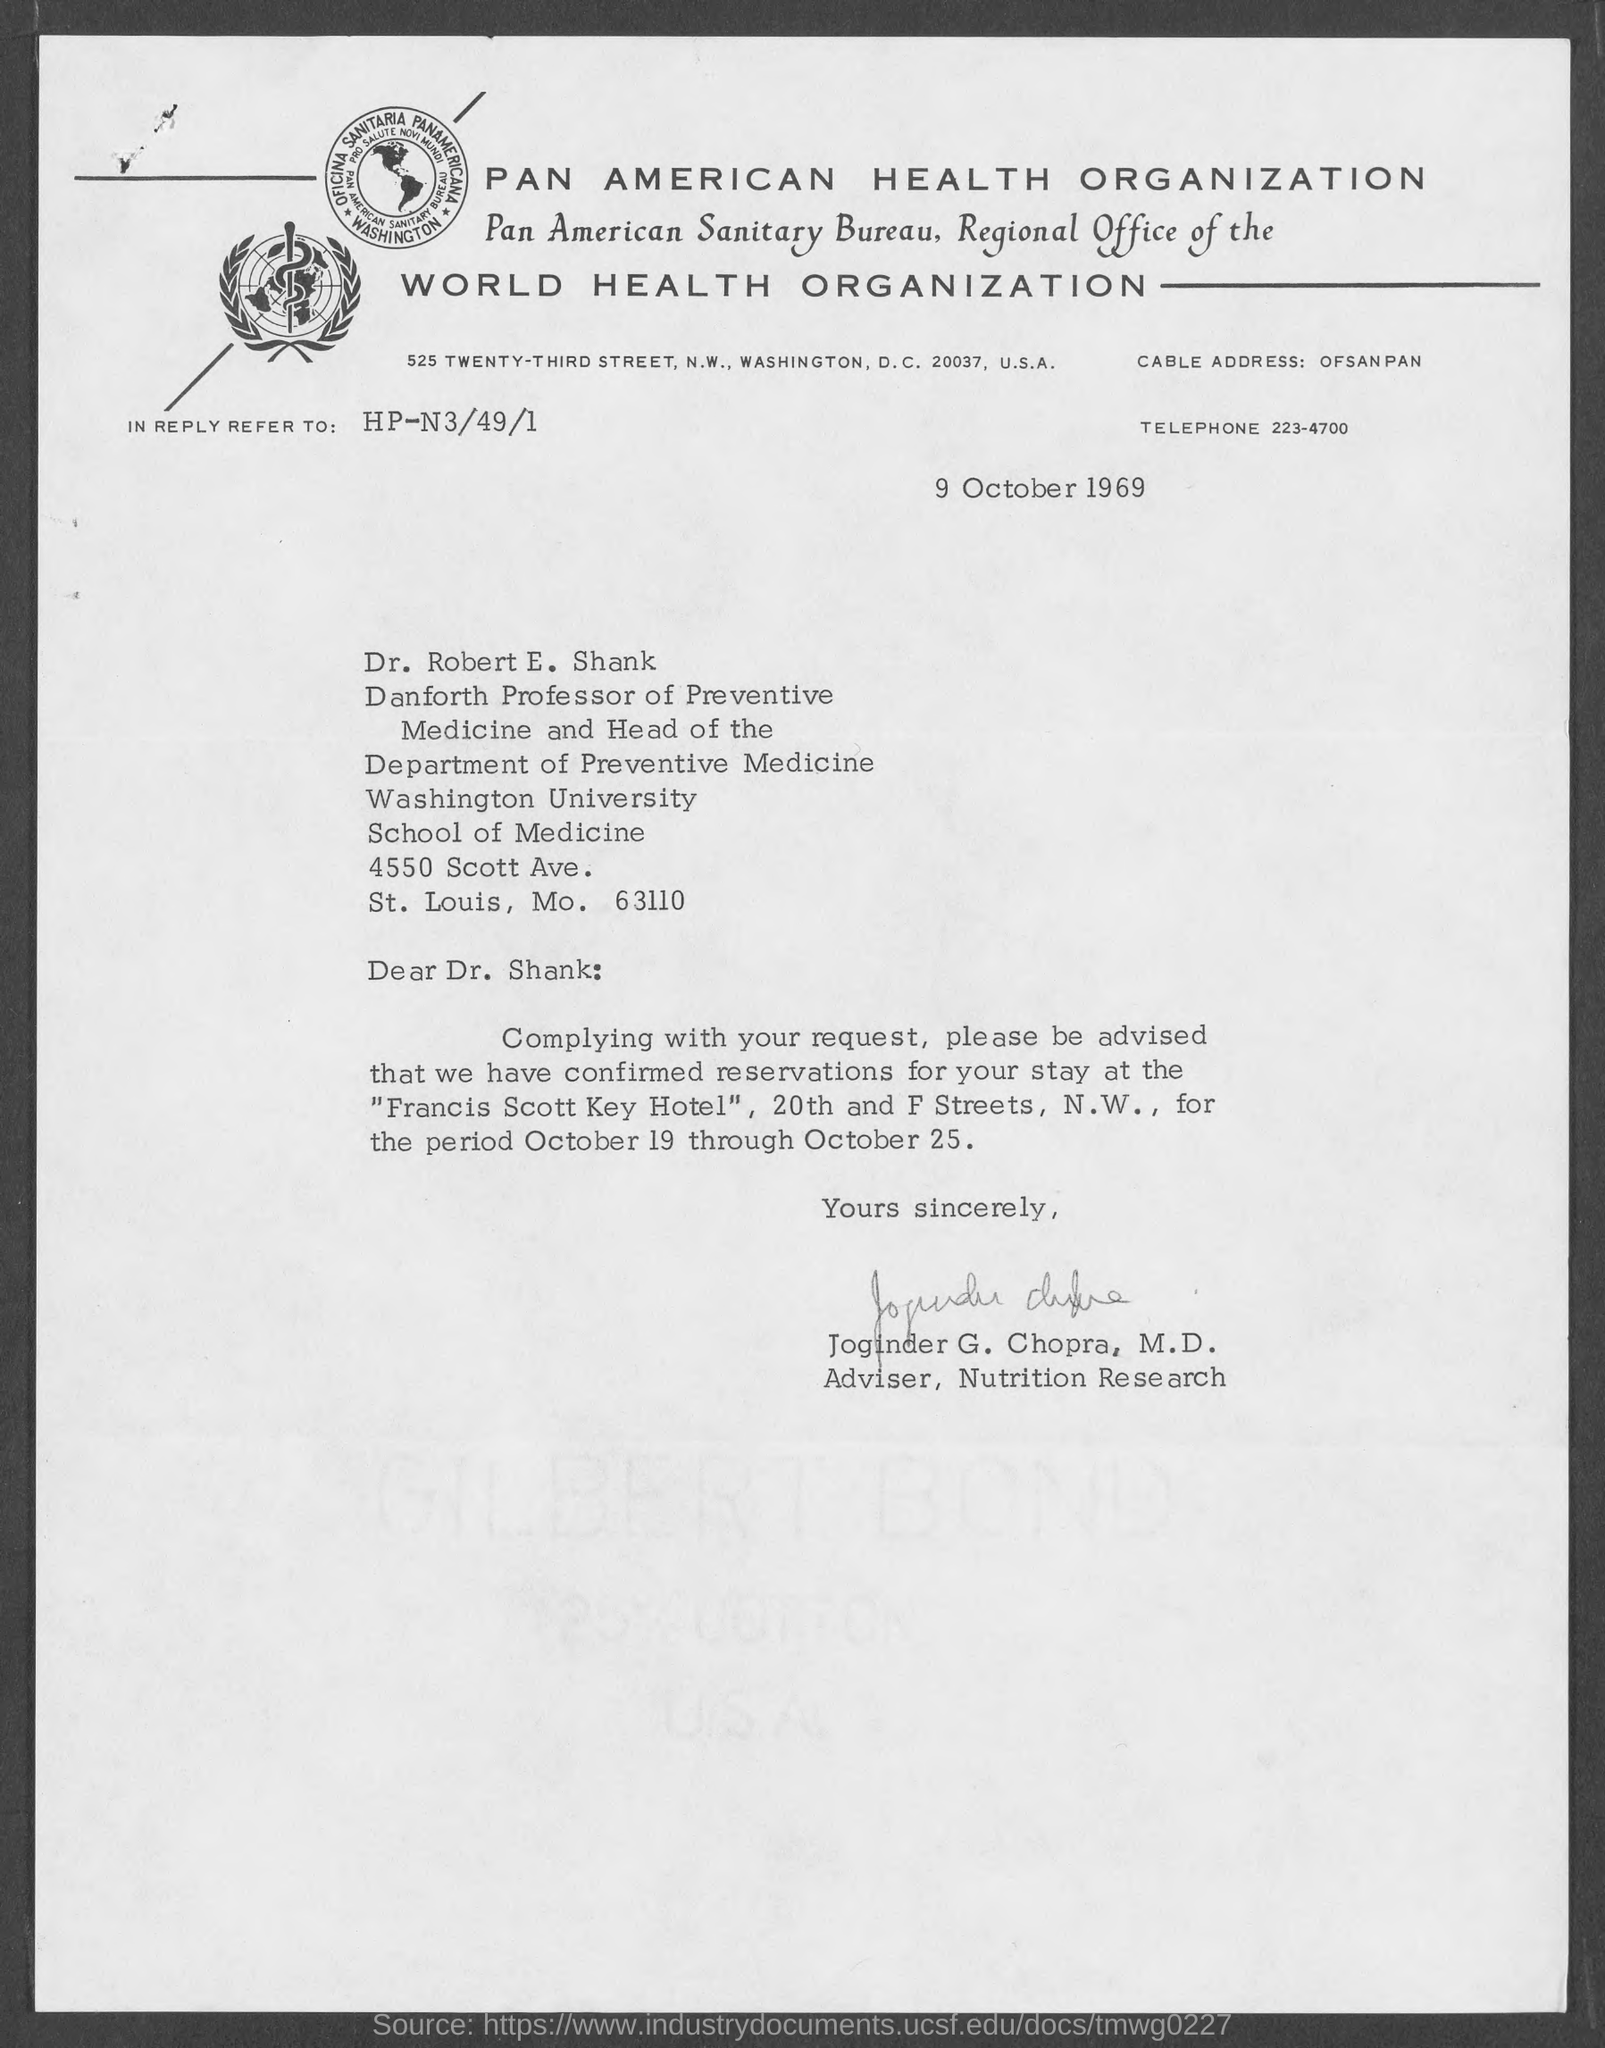Point out several critical features in this image. This letter is written to Dr. Robert E. Shank. The writer of this letter is Joginder G. Chopra. Joginder G. Chopra, M.D. holds the position of Adviser in Nutrition Research. 